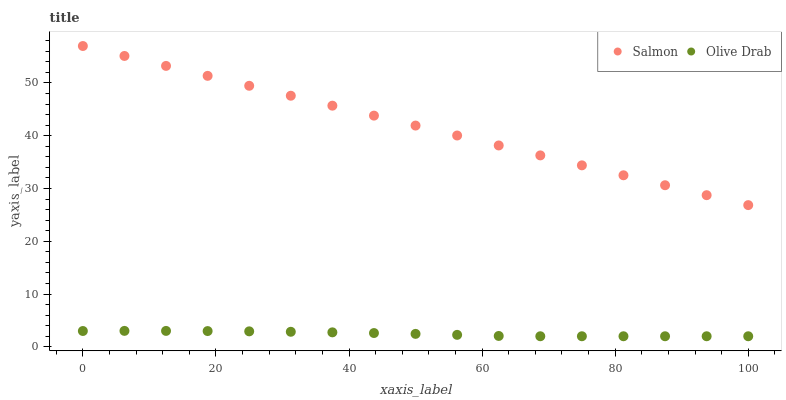Does Olive Drab have the minimum area under the curve?
Answer yes or no. Yes. Does Salmon have the maximum area under the curve?
Answer yes or no. Yes. Does Olive Drab have the maximum area under the curve?
Answer yes or no. No. Is Salmon the smoothest?
Answer yes or no. Yes. Is Olive Drab the roughest?
Answer yes or no. Yes. Is Olive Drab the smoothest?
Answer yes or no. No. Does Olive Drab have the lowest value?
Answer yes or no. Yes. Does Salmon have the highest value?
Answer yes or no. Yes. Does Olive Drab have the highest value?
Answer yes or no. No. Is Olive Drab less than Salmon?
Answer yes or no. Yes. Is Salmon greater than Olive Drab?
Answer yes or no. Yes. Does Olive Drab intersect Salmon?
Answer yes or no. No. 